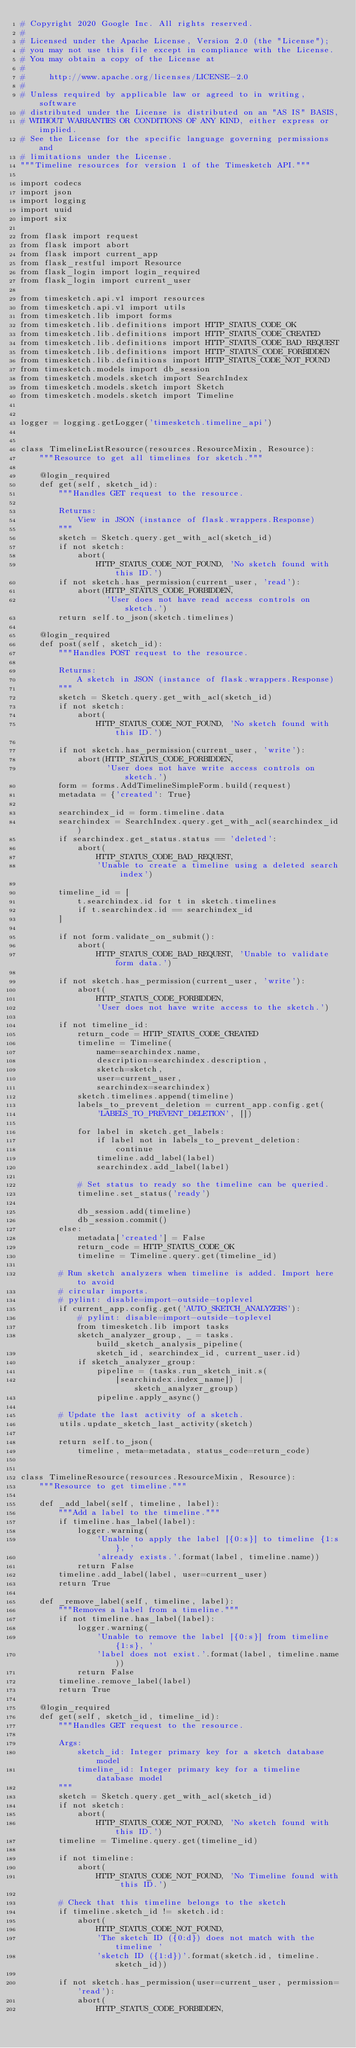<code> <loc_0><loc_0><loc_500><loc_500><_Python_># Copyright 2020 Google Inc. All rights reserved.
#
# Licensed under the Apache License, Version 2.0 (the "License");
# you may not use this file except in compliance with the License.
# You may obtain a copy of the License at
#
#     http://www.apache.org/licenses/LICENSE-2.0
#
# Unless required by applicable law or agreed to in writing, software
# distributed under the License is distributed on an "AS IS" BASIS,
# WITHOUT WARRANTIES OR CONDITIONS OF ANY KIND, either express or implied.
# See the License for the specific language governing permissions and
# limitations under the License.
"""Timeline resources for version 1 of the Timesketch API."""

import codecs
import json
import logging
import uuid
import six

from flask import request
from flask import abort
from flask import current_app
from flask_restful import Resource
from flask_login import login_required
from flask_login import current_user

from timesketch.api.v1 import resources
from timesketch.api.v1 import utils
from timesketch.lib import forms
from timesketch.lib.definitions import HTTP_STATUS_CODE_OK
from timesketch.lib.definitions import HTTP_STATUS_CODE_CREATED
from timesketch.lib.definitions import HTTP_STATUS_CODE_BAD_REQUEST
from timesketch.lib.definitions import HTTP_STATUS_CODE_FORBIDDEN
from timesketch.lib.definitions import HTTP_STATUS_CODE_NOT_FOUND
from timesketch.models import db_session
from timesketch.models.sketch import SearchIndex
from timesketch.models.sketch import Sketch
from timesketch.models.sketch import Timeline


logger = logging.getLogger('timesketch.timeline_api')


class TimelineListResource(resources.ResourceMixin, Resource):
    """Resource to get all timelines for sketch."""

    @login_required
    def get(self, sketch_id):
        """Handles GET request to the resource.

        Returns:
            View in JSON (instance of flask.wrappers.Response)
        """
        sketch = Sketch.query.get_with_acl(sketch_id)
        if not sketch:
            abort(
                HTTP_STATUS_CODE_NOT_FOUND, 'No sketch found with this ID.')
        if not sketch.has_permission(current_user, 'read'):
            abort(HTTP_STATUS_CODE_FORBIDDEN,
                  'User does not have read access controls on sketch.')
        return self.to_json(sketch.timelines)

    @login_required
    def post(self, sketch_id):
        """Handles POST request to the resource.

        Returns:
            A sketch in JSON (instance of flask.wrappers.Response)
        """
        sketch = Sketch.query.get_with_acl(sketch_id)
        if not sketch:
            abort(
                HTTP_STATUS_CODE_NOT_FOUND, 'No sketch found with this ID.')

        if not sketch.has_permission(current_user, 'write'):
            abort(HTTP_STATUS_CODE_FORBIDDEN,
                  'User does not have write access controls on sketch.')
        form = forms.AddTimelineSimpleForm.build(request)
        metadata = {'created': True}

        searchindex_id = form.timeline.data
        searchindex = SearchIndex.query.get_with_acl(searchindex_id)
        if searchindex.get_status.status == 'deleted':
            abort(
                HTTP_STATUS_CODE_BAD_REQUEST,
                'Unable to create a timeline using a deleted search index')

        timeline_id = [
            t.searchindex.id for t in sketch.timelines
            if t.searchindex.id == searchindex_id
        ]

        if not form.validate_on_submit():
            abort(
                HTTP_STATUS_CODE_BAD_REQUEST, 'Unable to validate form data.')

        if not sketch.has_permission(current_user, 'write'):
            abort(
                HTTP_STATUS_CODE_FORBIDDEN,
                'User does not have write access to the sketch.')

        if not timeline_id:
            return_code = HTTP_STATUS_CODE_CREATED
            timeline = Timeline(
                name=searchindex.name,
                description=searchindex.description,
                sketch=sketch,
                user=current_user,
                searchindex=searchindex)
            sketch.timelines.append(timeline)
            labels_to_prevent_deletion = current_app.config.get(
                'LABELS_TO_PREVENT_DELETION', [])

            for label in sketch.get_labels:
                if label not in labels_to_prevent_deletion:
                    continue
                timeline.add_label(label)
                searchindex.add_label(label)

            # Set status to ready so the timeline can be queried.
            timeline.set_status('ready')

            db_session.add(timeline)
            db_session.commit()
        else:
            metadata['created'] = False
            return_code = HTTP_STATUS_CODE_OK
            timeline = Timeline.query.get(timeline_id)

        # Run sketch analyzers when timeline is added. Import here to avoid
        # circular imports.
        # pylint: disable=import-outside-toplevel
        if current_app.config.get('AUTO_SKETCH_ANALYZERS'):
            # pylint: disable=import-outside-toplevel
            from timesketch.lib import tasks
            sketch_analyzer_group, _ = tasks.build_sketch_analysis_pipeline(
                sketch_id, searchindex_id, current_user.id)
            if sketch_analyzer_group:
                pipeline = (tasks.run_sketch_init.s(
                    [searchindex.index_name]) | sketch_analyzer_group)
                pipeline.apply_async()

        # Update the last activity of a sketch.
        utils.update_sketch_last_activity(sketch)

        return self.to_json(
            timeline, meta=metadata, status_code=return_code)


class TimelineResource(resources.ResourceMixin, Resource):
    """Resource to get timeline."""

    def _add_label(self, timeline, label):
        """Add a label to the timeline."""
        if timeline.has_label(label):
            logger.warning(
                'Unable to apply the label [{0:s}] to timeline {1:s}, '
                'already exists.'.format(label, timeline.name))
            return False
        timeline.add_label(label, user=current_user)
        return True

    def _remove_label(self, timeline, label):
        """Removes a label from a timeline."""
        if not timeline.has_label(label):
            logger.warning(
                'Unable to remove the label [{0:s}] from timeline {1:s}, '
                'label does not exist.'.format(label, timeline.name))
            return False
        timeline.remove_label(label)
        return True

    @login_required
    def get(self, sketch_id, timeline_id):
        """Handles GET request to the resource.

        Args:
            sketch_id: Integer primary key for a sketch database model
            timeline_id: Integer primary key for a timeline database model
        """
        sketch = Sketch.query.get_with_acl(sketch_id)
        if not sketch:
            abort(
                HTTP_STATUS_CODE_NOT_FOUND, 'No sketch found with this ID.')
        timeline = Timeline.query.get(timeline_id)

        if not timeline:
            abort(
                HTTP_STATUS_CODE_NOT_FOUND, 'No Timeline found with this ID.')

        # Check that this timeline belongs to the sketch
        if timeline.sketch_id != sketch.id:
            abort(
                HTTP_STATUS_CODE_NOT_FOUND,
                'The sketch ID ({0:d}) does not match with the timeline '
                'sketch ID ({1:d})'.format(sketch.id, timeline.sketch_id))

        if not sketch.has_permission(user=current_user, permission='read'):
            abort(
                HTTP_STATUS_CODE_FORBIDDEN,</code> 